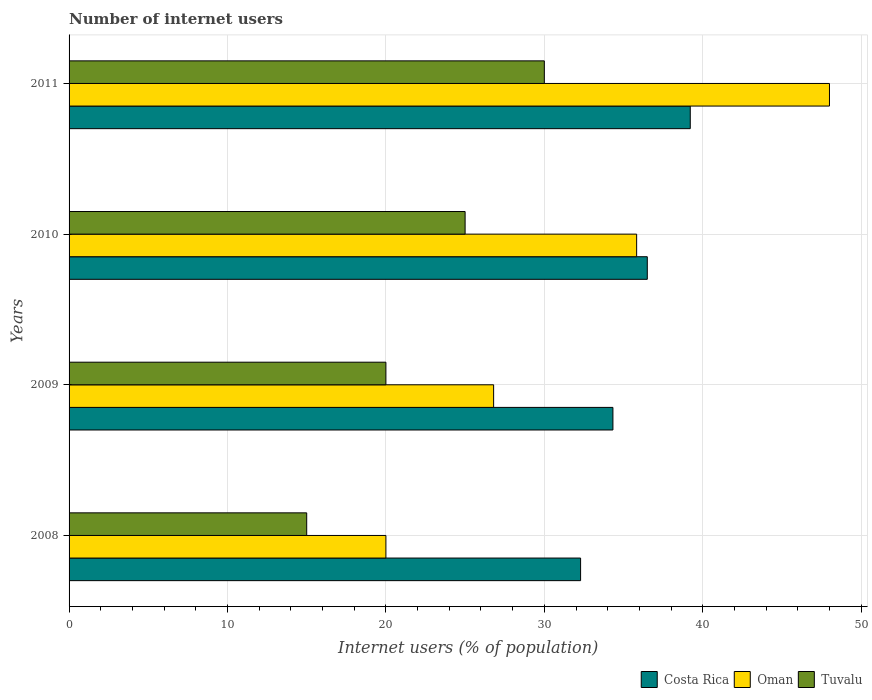How many bars are there on the 4th tick from the bottom?
Your answer should be very brief. 3. In how many cases, is the number of bars for a given year not equal to the number of legend labels?
Keep it short and to the point. 0. Across all years, what is the maximum number of internet users in Costa Rica?
Offer a very short reply. 39.21. What is the total number of internet users in Oman in the graph?
Your response must be concise. 130.63. What is the difference between the number of internet users in Oman in 2008 and that in 2010?
Your answer should be very brief. -15.83. What is the average number of internet users in Oman per year?
Keep it short and to the point. 32.66. In the year 2011, what is the difference between the number of internet users in Tuvalu and number of internet users in Costa Rica?
Give a very brief answer. -9.21. In how many years, is the number of internet users in Tuvalu greater than 46 %?
Keep it short and to the point. 0. What is the ratio of the number of internet users in Costa Rica in 2010 to that in 2011?
Make the answer very short. 0.93. What is the difference between the highest and the second highest number of internet users in Oman?
Offer a terse response. 12.17. What is the difference between the highest and the lowest number of internet users in Costa Rica?
Offer a terse response. 6.92. Is the sum of the number of internet users in Oman in 2008 and 2011 greater than the maximum number of internet users in Costa Rica across all years?
Keep it short and to the point. Yes. What does the 1st bar from the bottom in 2011 represents?
Your answer should be compact. Costa Rica. How many bars are there?
Provide a short and direct response. 12. How many years are there in the graph?
Offer a terse response. 4. Are the values on the major ticks of X-axis written in scientific E-notation?
Keep it short and to the point. No. How many legend labels are there?
Provide a succinct answer. 3. How are the legend labels stacked?
Keep it short and to the point. Horizontal. What is the title of the graph?
Offer a terse response. Number of internet users. Does "South Asia" appear as one of the legend labels in the graph?
Offer a very short reply. No. What is the label or title of the X-axis?
Your answer should be compact. Internet users (% of population). What is the Internet users (% of population) of Costa Rica in 2008?
Provide a succinct answer. 32.29. What is the Internet users (% of population) of Oman in 2008?
Keep it short and to the point. 20. What is the Internet users (% of population) in Costa Rica in 2009?
Give a very brief answer. 34.33. What is the Internet users (% of population) in Oman in 2009?
Provide a short and direct response. 26.8. What is the Internet users (% of population) of Costa Rica in 2010?
Make the answer very short. 36.5. What is the Internet users (% of population) in Oman in 2010?
Give a very brief answer. 35.83. What is the Internet users (% of population) in Tuvalu in 2010?
Provide a succinct answer. 25. What is the Internet users (% of population) of Costa Rica in 2011?
Ensure brevity in your answer.  39.21. What is the Internet users (% of population) in Oman in 2011?
Offer a very short reply. 48. What is the Internet users (% of population) of Tuvalu in 2011?
Your answer should be compact. 30. Across all years, what is the maximum Internet users (% of population) in Costa Rica?
Offer a terse response. 39.21. Across all years, what is the maximum Internet users (% of population) in Tuvalu?
Provide a short and direct response. 30. Across all years, what is the minimum Internet users (% of population) in Costa Rica?
Your answer should be very brief. 32.29. Across all years, what is the minimum Internet users (% of population) of Oman?
Provide a succinct answer. 20. Across all years, what is the minimum Internet users (% of population) of Tuvalu?
Give a very brief answer. 15. What is the total Internet users (% of population) in Costa Rica in the graph?
Make the answer very short. 142.33. What is the total Internet users (% of population) in Oman in the graph?
Give a very brief answer. 130.63. What is the total Internet users (% of population) of Tuvalu in the graph?
Provide a succinct answer. 90. What is the difference between the Internet users (% of population) in Costa Rica in 2008 and that in 2009?
Make the answer very short. -2.04. What is the difference between the Internet users (% of population) in Oman in 2008 and that in 2009?
Provide a short and direct response. -6.8. What is the difference between the Internet users (% of population) of Tuvalu in 2008 and that in 2009?
Provide a succinct answer. -5. What is the difference between the Internet users (% of population) of Costa Rica in 2008 and that in 2010?
Your answer should be very brief. -4.21. What is the difference between the Internet users (% of population) of Oman in 2008 and that in 2010?
Offer a terse response. -15.83. What is the difference between the Internet users (% of population) of Costa Rica in 2008 and that in 2011?
Ensure brevity in your answer.  -6.92. What is the difference between the Internet users (% of population) in Tuvalu in 2008 and that in 2011?
Your response must be concise. -15. What is the difference between the Internet users (% of population) in Costa Rica in 2009 and that in 2010?
Make the answer very short. -2.17. What is the difference between the Internet users (% of population) in Oman in 2009 and that in 2010?
Your answer should be very brief. -9.03. What is the difference between the Internet users (% of population) in Costa Rica in 2009 and that in 2011?
Offer a terse response. -4.88. What is the difference between the Internet users (% of population) of Oman in 2009 and that in 2011?
Your response must be concise. -21.2. What is the difference between the Internet users (% of population) in Tuvalu in 2009 and that in 2011?
Give a very brief answer. -10. What is the difference between the Internet users (% of population) in Costa Rica in 2010 and that in 2011?
Offer a terse response. -2.71. What is the difference between the Internet users (% of population) of Oman in 2010 and that in 2011?
Your response must be concise. -12.17. What is the difference between the Internet users (% of population) in Tuvalu in 2010 and that in 2011?
Provide a short and direct response. -5. What is the difference between the Internet users (% of population) of Costa Rica in 2008 and the Internet users (% of population) of Oman in 2009?
Your response must be concise. 5.49. What is the difference between the Internet users (% of population) of Costa Rica in 2008 and the Internet users (% of population) of Tuvalu in 2009?
Offer a terse response. 12.29. What is the difference between the Internet users (% of population) in Oman in 2008 and the Internet users (% of population) in Tuvalu in 2009?
Provide a short and direct response. 0. What is the difference between the Internet users (% of population) in Costa Rica in 2008 and the Internet users (% of population) in Oman in 2010?
Provide a short and direct response. -3.54. What is the difference between the Internet users (% of population) in Costa Rica in 2008 and the Internet users (% of population) in Tuvalu in 2010?
Provide a succinct answer. 7.29. What is the difference between the Internet users (% of population) in Costa Rica in 2008 and the Internet users (% of population) in Oman in 2011?
Your answer should be compact. -15.71. What is the difference between the Internet users (% of population) in Costa Rica in 2008 and the Internet users (% of population) in Tuvalu in 2011?
Your response must be concise. 2.29. What is the difference between the Internet users (% of population) in Oman in 2008 and the Internet users (% of population) in Tuvalu in 2011?
Your answer should be compact. -10. What is the difference between the Internet users (% of population) in Costa Rica in 2009 and the Internet users (% of population) in Oman in 2010?
Your response must be concise. -1.5. What is the difference between the Internet users (% of population) in Costa Rica in 2009 and the Internet users (% of population) in Tuvalu in 2010?
Your response must be concise. 9.33. What is the difference between the Internet users (% of population) of Costa Rica in 2009 and the Internet users (% of population) of Oman in 2011?
Make the answer very short. -13.67. What is the difference between the Internet users (% of population) in Costa Rica in 2009 and the Internet users (% of population) in Tuvalu in 2011?
Provide a succinct answer. 4.33. What is the difference between the Internet users (% of population) of Costa Rica in 2010 and the Internet users (% of population) of Oman in 2011?
Your response must be concise. -11.5. What is the difference between the Internet users (% of population) of Oman in 2010 and the Internet users (% of population) of Tuvalu in 2011?
Provide a succinct answer. 5.83. What is the average Internet users (% of population) of Costa Rica per year?
Offer a very short reply. 35.58. What is the average Internet users (% of population) in Oman per year?
Your answer should be very brief. 32.66. What is the average Internet users (% of population) of Tuvalu per year?
Keep it short and to the point. 22.5. In the year 2008, what is the difference between the Internet users (% of population) in Costa Rica and Internet users (% of population) in Oman?
Offer a very short reply. 12.29. In the year 2008, what is the difference between the Internet users (% of population) of Costa Rica and Internet users (% of population) of Tuvalu?
Your response must be concise. 17.29. In the year 2008, what is the difference between the Internet users (% of population) of Oman and Internet users (% of population) of Tuvalu?
Your answer should be compact. 5. In the year 2009, what is the difference between the Internet users (% of population) of Costa Rica and Internet users (% of population) of Oman?
Offer a very short reply. 7.53. In the year 2009, what is the difference between the Internet users (% of population) in Costa Rica and Internet users (% of population) in Tuvalu?
Your answer should be compact. 14.33. In the year 2010, what is the difference between the Internet users (% of population) of Costa Rica and Internet users (% of population) of Oman?
Keep it short and to the point. 0.67. In the year 2010, what is the difference between the Internet users (% of population) of Oman and Internet users (% of population) of Tuvalu?
Your response must be concise. 10.83. In the year 2011, what is the difference between the Internet users (% of population) of Costa Rica and Internet users (% of population) of Oman?
Your response must be concise. -8.79. In the year 2011, what is the difference between the Internet users (% of population) in Costa Rica and Internet users (% of population) in Tuvalu?
Your answer should be very brief. 9.21. What is the ratio of the Internet users (% of population) in Costa Rica in 2008 to that in 2009?
Your answer should be very brief. 0.94. What is the ratio of the Internet users (% of population) of Oman in 2008 to that in 2009?
Offer a terse response. 0.75. What is the ratio of the Internet users (% of population) of Tuvalu in 2008 to that in 2009?
Provide a succinct answer. 0.75. What is the ratio of the Internet users (% of population) of Costa Rica in 2008 to that in 2010?
Give a very brief answer. 0.88. What is the ratio of the Internet users (% of population) in Oman in 2008 to that in 2010?
Keep it short and to the point. 0.56. What is the ratio of the Internet users (% of population) of Costa Rica in 2008 to that in 2011?
Give a very brief answer. 0.82. What is the ratio of the Internet users (% of population) of Oman in 2008 to that in 2011?
Make the answer very short. 0.42. What is the ratio of the Internet users (% of population) of Costa Rica in 2009 to that in 2010?
Ensure brevity in your answer.  0.94. What is the ratio of the Internet users (% of population) of Oman in 2009 to that in 2010?
Your response must be concise. 0.75. What is the ratio of the Internet users (% of population) of Tuvalu in 2009 to that in 2010?
Give a very brief answer. 0.8. What is the ratio of the Internet users (% of population) in Costa Rica in 2009 to that in 2011?
Your answer should be compact. 0.88. What is the ratio of the Internet users (% of population) in Oman in 2009 to that in 2011?
Provide a succinct answer. 0.56. What is the ratio of the Internet users (% of population) of Tuvalu in 2009 to that in 2011?
Keep it short and to the point. 0.67. What is the ratio of the Internet users (% of population) of Costa Rica in 2010 to that in 2011?
Provide a succinct answer. 0.93. What is the ratio of the Internet users (% of population) of Oman in 2010 to that in 2011?
Offer a very short reply. 0.75. What is the difference between the highest and the second highest Internet users (% of population) in Costa Rica?
Your response must be concise. 2.71. What is the difference between the highest and the second highest Internet users (% of population) of Oman?
Your answer should be very brief. 12.17. What is the difference between the highest and the second highest Internet users (% of population) of Tuvalu?
Offer a very short reply. 5. What is the difference between the highest and the lowest Internet users (% of population) in Costa Rica?
Offer a very short reply. 6.92. What is the difference between the highest and the lowest Internet users (% of population) of Oman?
Offer a terse response. 28. 